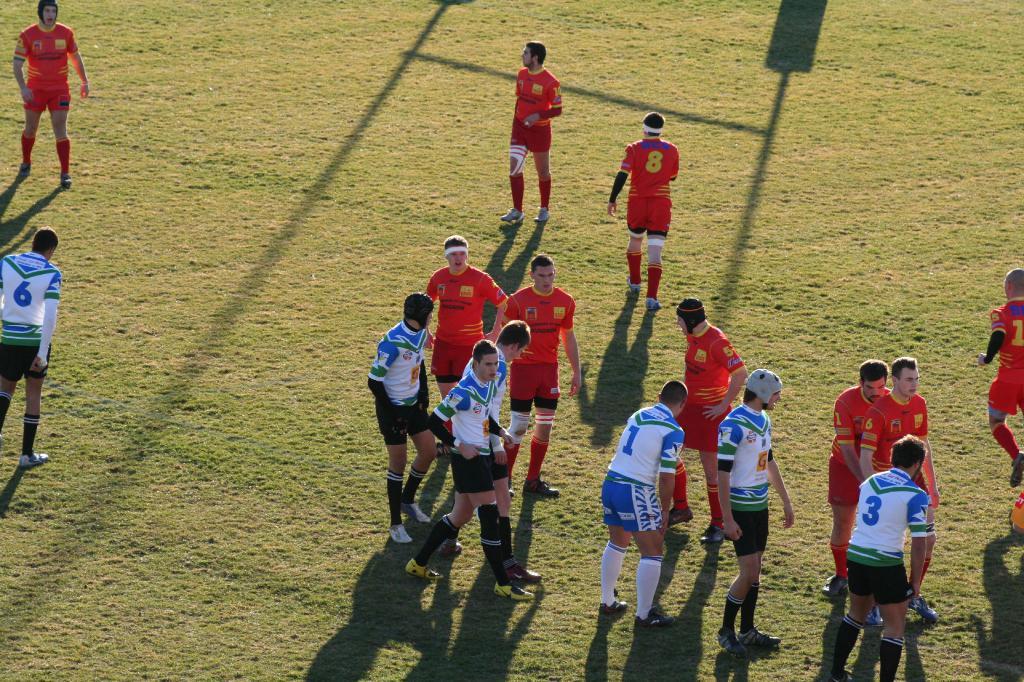What number is the player in the white jersey to the far left?
Offer a terse response. 6. 